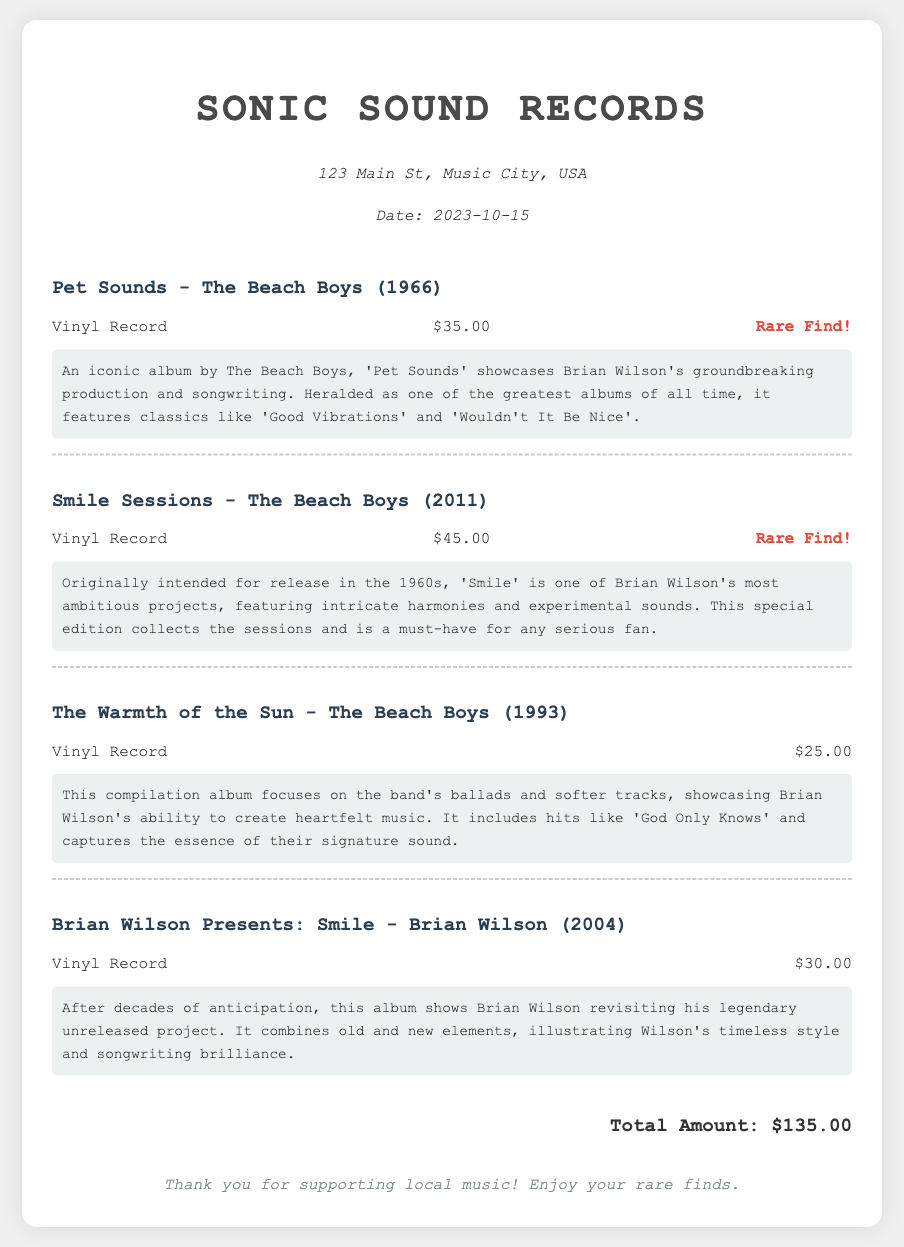what is the total amount spent? The total amount is calculated from the total of all vinyl records purchased, which is displayed at the end of the receipt.
Answer: $135.00 what are the titles of the rare finds? The item details specifically highlight which records are rare finds, indicated by the phrase 'Rare Find!'.
Answer: Pet Sounds, Smile Sessions who is the artist of 'Pet Sounds'? The artist associated with the title 'Pet Sounds' is mentioned in the item details of the receipt.
Answer: The Beach Boys when was 'Smile Sessions' released? The release year of 'Smile Sessions' is provided next to its title in the document.
Answer: 2011 how much does 'Brian Wilson Presents: Smile' cost? The price of 'Brian Wilson Presents: Smile' is listed in the item details section of the receipt.
Answer: $30.00 what does the biography of 'The Warmth of the Sun' focus on? The biography description highlights the theme of the compilation album, specifically what type of tracks it includes.
Answer: Ballads and softer tracks how many albums by The Beach Boys are listed on this receipt? By counting the items displayed in the receipt, you can determine the number of albums by The Beach Boys included.
Answer: Three albums what is the address of Sonic Sound Records? The store's location details are provided at the top of the receipt under store info.
Answer: 123 Main St, Music City, USA 